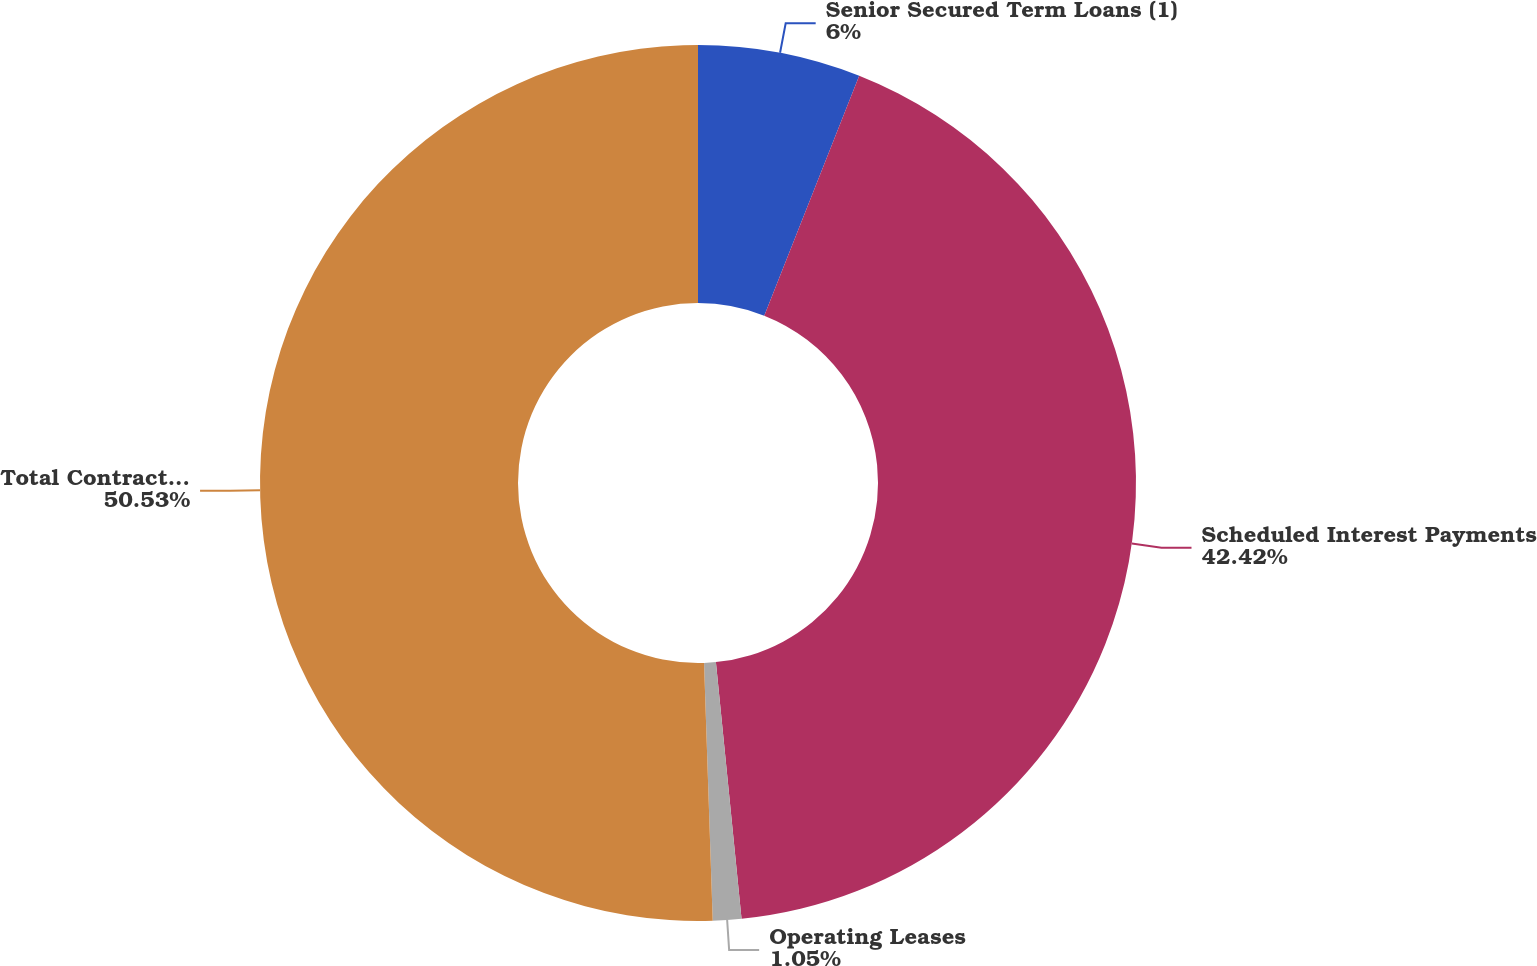<chart> <loc_0><loc_0><loc_500><loc_500><pie_chart><fcel>Senior Secured Term Loans (1)<fcel>Scheduled Interest Payments<fcel>Operating Leases<fcel>Total Contractual Cash<nl><fcel>6.0%<fcel>42.42%<fcel>1.05%<fcel>50.54%<nl></chart> 